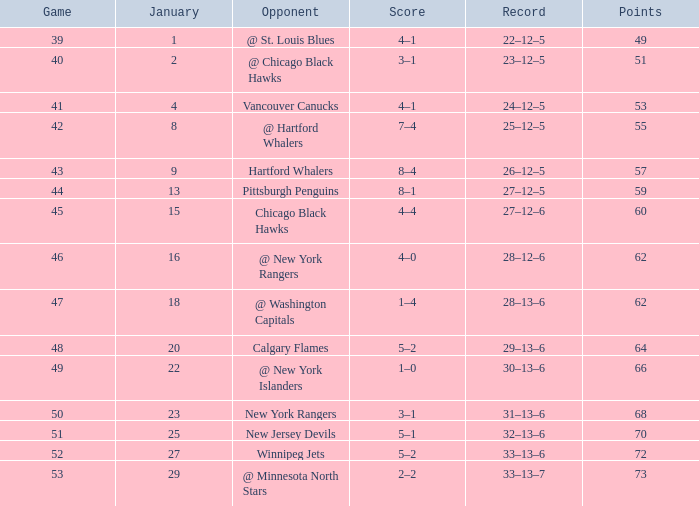Which Points is the lowest one that has a Score of 1–4, and a January smaller than 18? None. 